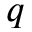Convert formula to latex. <formula><loc_0><loc_0><loc_500><loc_500>q</formula> 